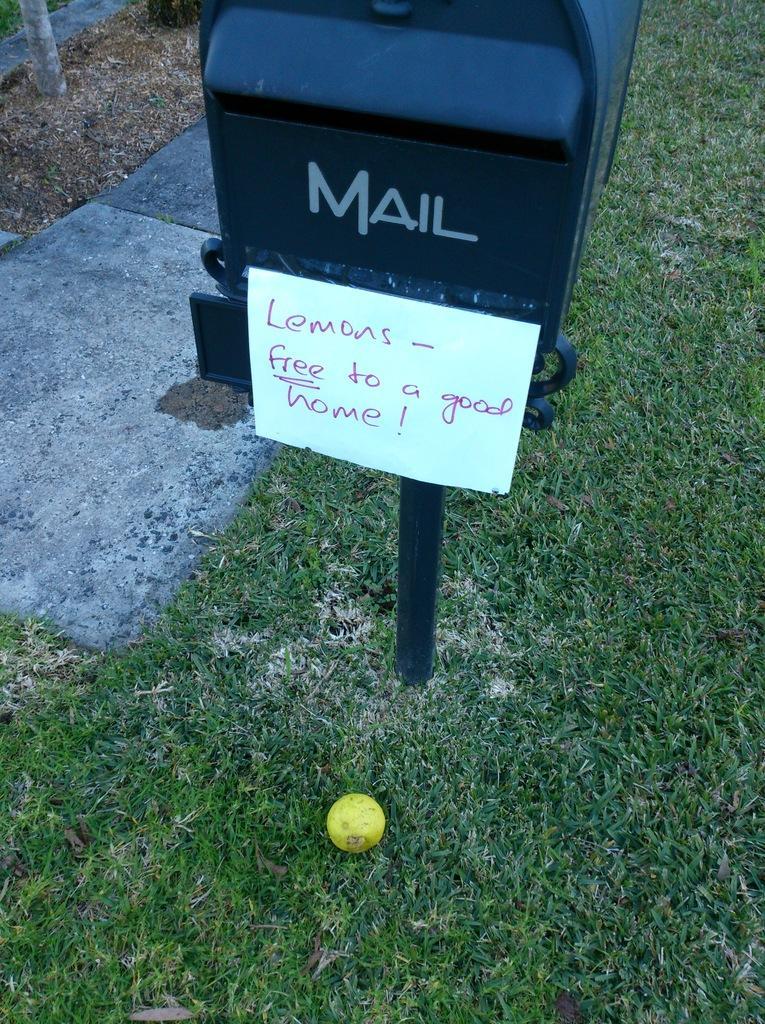Could you give a brief overview of what you see in this image? In this picture we can see a ball on the grass. We can see a mailbox. There is some text on a whiteboard. This white board is visible on a mailbox. 